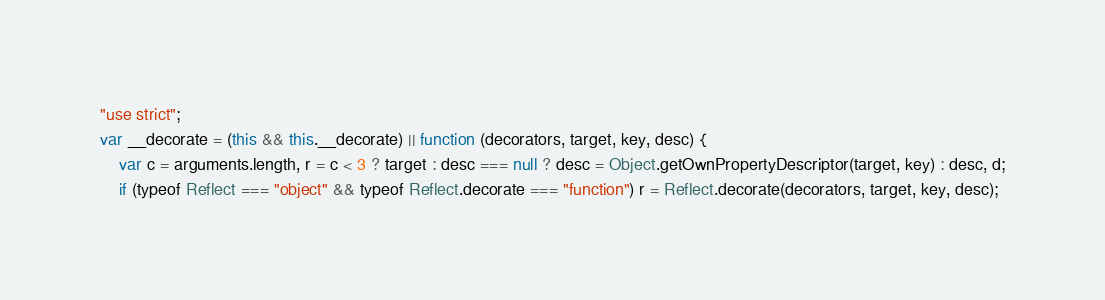<code> <loc_0><loc_0><loc_500><loc_500><_JavaScript_>"use strict";
var __decorate = (this && this.__decorate) || function (decorators, target, key, desc) {
    var c = arguments.length, r = c < 3 ? target : desc === null ? desc = Object.getOwnPropertyDescriptor(target, key) : desc, d;
    if (typeof Reflect === "object" && typeof Reflect.decorate === "function") r = Reflect.decorate(decorators, target, key, desc);</code> 